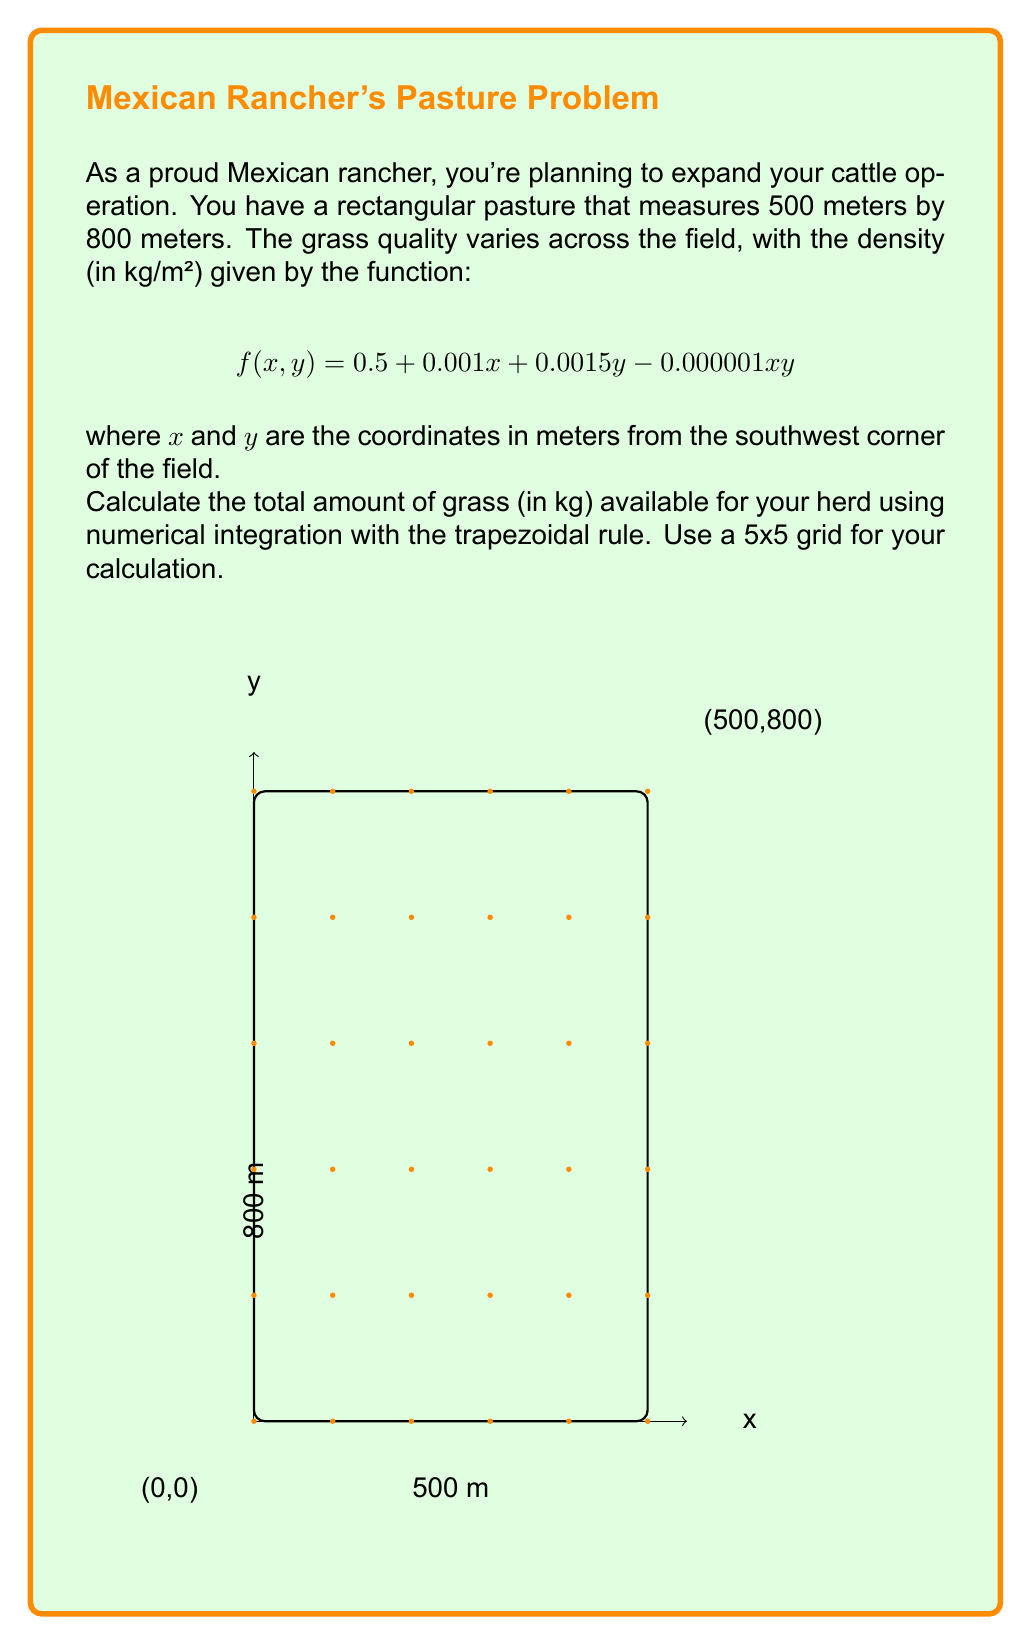Show me your answer to this math problem. Let's approach this step-by-step:

1) First, we need to divide our field into a 5x5 grid. This means:
   $\Delta x = 500/5 = 100$ meters
   $\Delta y = 800/5 = 160$ meters

2) We'll evaluate f(x,y) at each of the 36 grid points (6x6 including edges).

3) The trapezoidal rule for double integrals is:

   $$\int_{a}^{b}\int_{c}^{d} f(x,y) dy dx \approx \frac{\Delta x \Delta y}{4} [f(x_0,y_0) + f(x_n,y_0) + f(x_0,y_m) + f(x_n,y_m) + 2\sum_{i=1}^{n-1}f(x_i,y_0) + 2\sum_{j=1}^{m-1}f(x_0,y_j) + 2\sum_{i=1}^{n-1}f(x_i,y_m) + 2\sum_{j=1}^{m-1}f(x_n,y_j) + 4\sum_{i=1}^{n-1}\sum_{j=1}^{m-1}f(x_i,y_j)]$$

4) Let's evaluate f(x,y) at each point:

   f(0,0) = 0.5
   f(500,0) = 1.0
   f(0,800) = 1.7
   f(500,800) = 2.2

   Sum of corner points: 5.4

5) Sum of edge points (excluding corners):
   Bottom edge: 2(0.6 + 0.7 + 0.8 + 0.9) = 6
   Left edge: 2(0.74 + 0.98 + 1.22 + 1.46) = 8.8
   Top edge: 2(1.8 + 1.9 + 2.0 + 2.1) = 15.6
   Right edge: 2(1.24 + 1.48 + 1.72 + 1.96) = 12.8

   Total of edge points: 43.2

6) Sum of interior points:
   4(0.84 + 0.94 + 1.04 + 1.14 +
     1.08 + 1.18 + 1.28 + 1.38 +
     1.32 + 1.42 + 1.52 + 1.62 +
     1.56 + 1.66 + 1.76 + 1.86) = 78.56

7) Applying the formula:
   $\frac{100 * 160}{4} [5.4 + 43.2 + 78.56] = 400,000 * 127.16 = 50,864,000$

Therefore, the total amount of grass available is approximately 50,864,000 kg.
Answer: 50,864,000 kg 